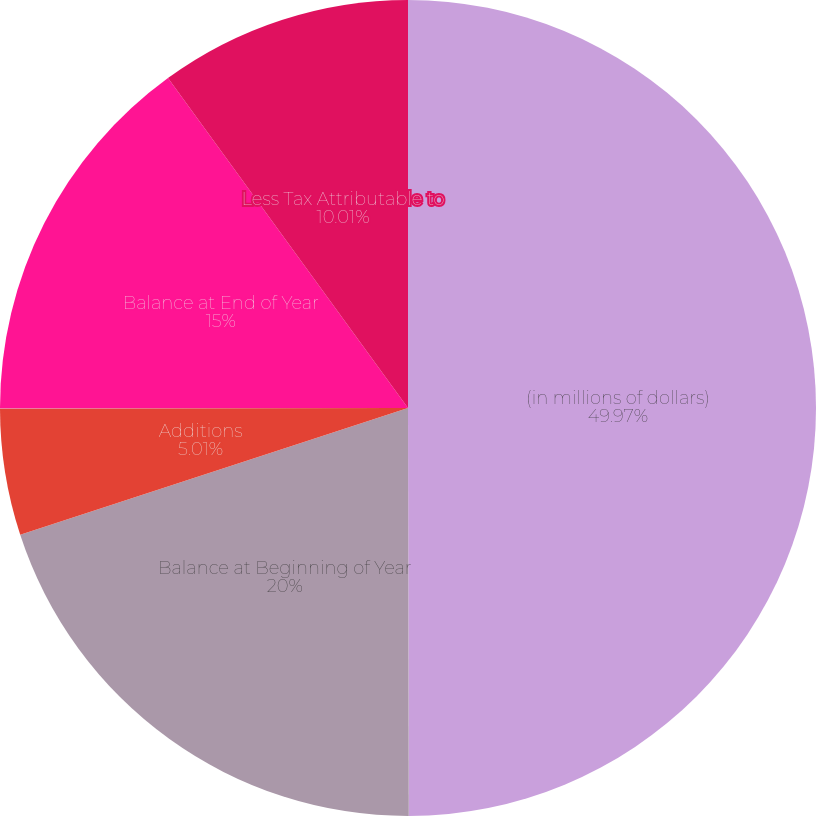<chart> <loc_0><loc_0><loc_500><loc_500><pie_chart><fcel>(in millions of dollars)<fcel>Balance at Beginning of Year<fcel>Additions<fcel>Subtractions<fcel>Balance at End of Year<fcel>Less Tax Attributable to<nl><fcel>49.97%<fcel>20.0%<fcel>5.01%<fcel>0.01%<fcel>15.0%<fcel>10.01%<nl></chart> 